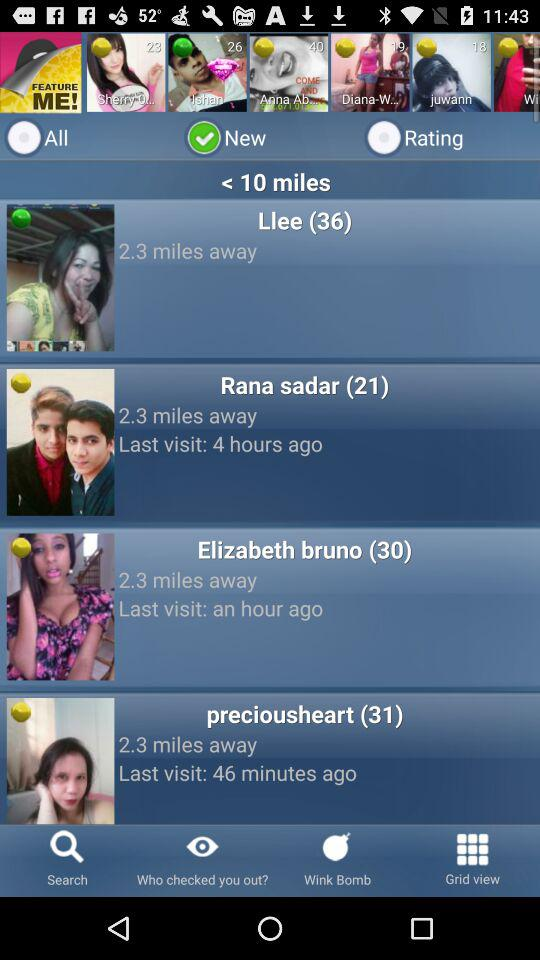How far is "preciousheart" from my location? "preciousheart" is 2.3 miles away from your location. 